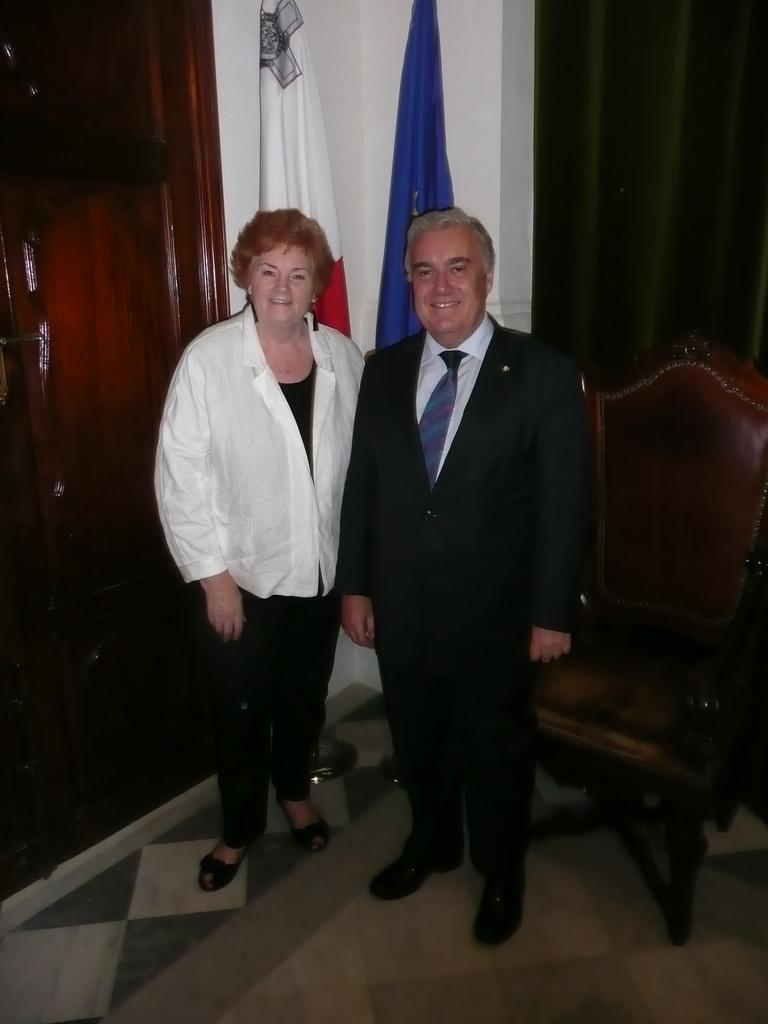How many people are present in the image? There are two people in the image, a man and a woman. What are the man and woman doing in the image? Both the man and woman are standing and smiling. What type of furniture can be seen in the image? There are chairs in the image. What architectural feature is present in the image? There is a door in the image. How many flags are visible in the image? There are two flags in the image. What type of laborer is working on the development project in the image? There is no laborer or development project present in the image. What type of loss is depicted in the image? There is no loss depicted in the image; it features a man and woman standing and smiling. 